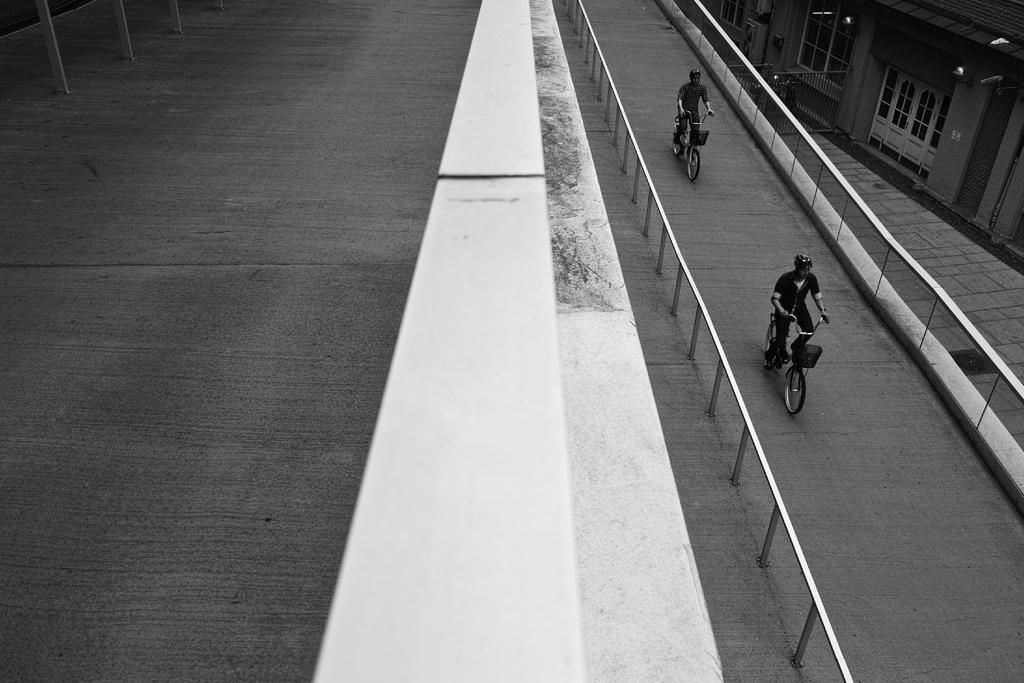What is the color scheme of the image? The image is black and white. How many people are in the image? There are two persons in the image. What are the persons doing in the image? The persons are riding bicycles. What can be seen in the background of the image? There is a road, a fence, and a house in the image. What type of boot can be seen floating in space in the image? There is no boot or space present in the image; it features two persons riding bicycles in a black and white setting with a road, fence, and house in the background. 